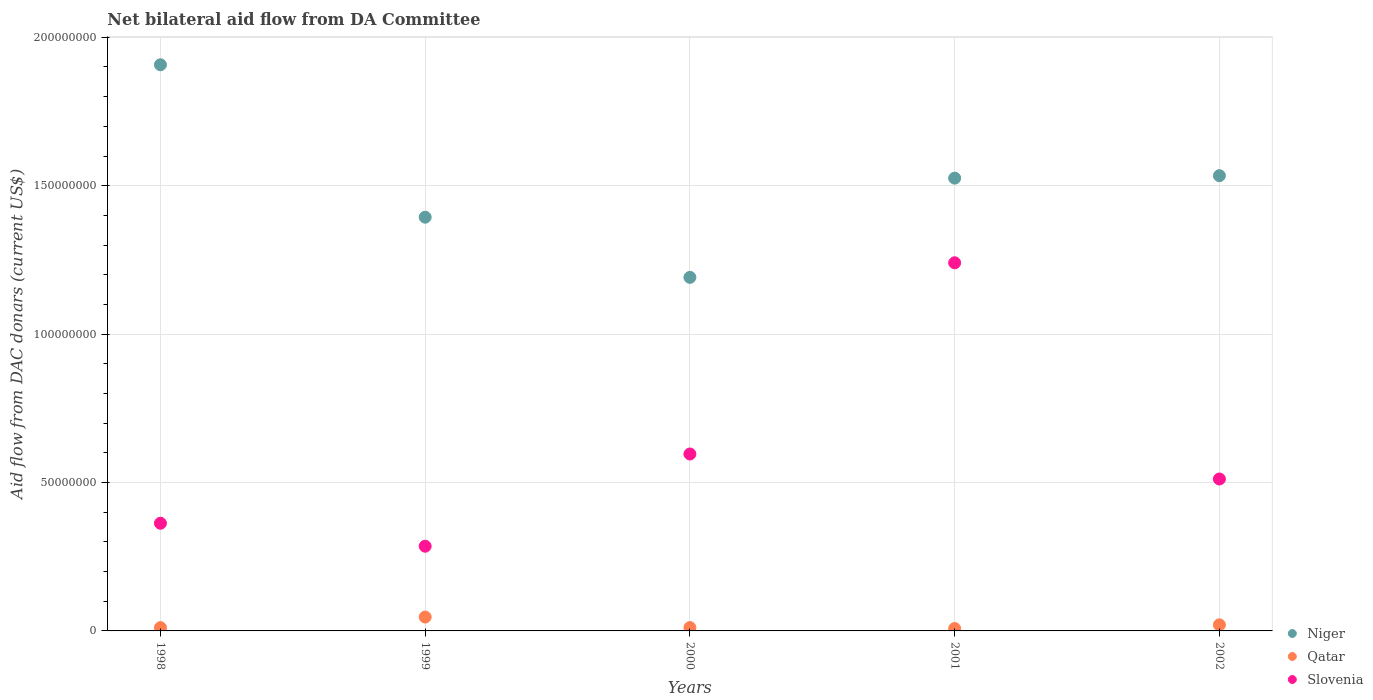How many different coloured dotlines are there?
Give a very brief answer. 3. Is the number of dotlines equal to the number of legend labels?
Provide a succinct answer. Yes. What is the aid flow in in Niger in 1998?
Keep it short and to the point. 1.91e+08. Across all years, what is the maximum aid flow in in Slovenia?
Your answer should be very brief. 1.24e+08. Across all years, what is the minimum aid flow in in Qatar?
Offer a very short reply. 8.10e+05. In which year was the aid flow in in Slovenia maximum?
Make the answer very short. 2001. What is the total aid flow in in Qatar in the graph?
Offer a very short reply. 9.77e+06. What is the difference between the aid flow in in Niger in 1999 and that in 2000?
Your answer should be compact. 2.03e+07. What is the difference between the aid flow in in Niger in 2002 and the aid flow in in Slovenia in 2000?
Your answer should be compact. 9.38e+07. What is the average aid flow in in Qatar per year?
Ensure brevity in your answer.  1.95e+06. In the year 1998, what is the difference between the aid flow in in Qatar and aid flow in in Slovenia?
Offer a very short reply. -3.52e+07. What is the ratio of the aid flow in in Qatar in 1999 to that in 2001?
Provide a succinct answer. 5.78. Is the aid flow in in Qatar in 1999 less than that in 2002?
Give a very brief answer. No. What is the difference between the highest and the second highest aid flow in in Slovenia?
Your answer should be compact. 6.44e+07. What is the difference between the highest and the lowest aid flow in in Qatar?
Your answer should be very brief. 3.87e+06. Is the aid flow in in Niger strictly greater than the aid flow in in Slovenia over the years?
Offer a very short reply. Yes. How many years are there in the graph?
Your answer should be very brief. 5. Does the graph contain any zero values?
Make the answer very short. No. Does the graph contain grids?
Ensure brevity in your answer.  Yes. Where does the legend appear in the graph?
Give a very brief answer. Bottom right. How many legend labels are there?
Provide a short and direct response. 3. How are the legend labels stacked?
Ensure brevity in your answer.  Vertical. What is the title of the graph?
Offer a very short reply. Net bilateral aid flow from DA Committee. What is the label or title of the X-axis?
Provide a short and direct response. Years. What is the label or title of the Y-axis?
Give a very brief answer. Aid flow from DAC donars (current US$). What is the Aid flow from DAC donars (current US$) of Niger in 1998?
Your response must be concise. 1.91e+08. What is the Aid flow from DAC donars (current US$) in Qatar in 1998?
Offer a terse response. 1.11e+06. What is the Aid flow from DAC donars (current US$) of Slovenia in 1998?
Keep it short and to the point. 3.63e+07. What is the Aid flow from DAC donars (current US$) of Niger in 1999?
Keep it short and to the point. 1.39e+08. What is the Aid flow from DAC donars (current US$) in Qatar in 1999?
Keep it short and to the point. 4.68e+06. What is the Aid flow from DAC donars (current US$) of Slovenia in 1999?
Provide a short and direct response. 2.85e+07. What is the Aid flow from DAC donars (current US$) in Niger in 2000?
Your response must be concise. 1.19e+08. What is the Aid flow from DAC donars (current US$) in Qatar in 2000?
Your answer should be compact. 1.12e+06. What is the Aid flow from DAC donars (current US$) in Slovenia in 2000?
Give a very brief answer. 5.96e+07. What is the Aid flow from DAC donars (current US$) of Niger in 2001?
Your answer should be very brief. 1.53e+08. What is the Aid flow from DAC donars (current US$) in Qatar in 2001?
Ensure brevity in your answer.  8.10e+05. What is the Aid flow from DAC donars (current US$) of Slovenia in 2001?
Provide a succinct answer. 1.24e+08. What is the Aid flow from DAC donars (current US$) of Niger in 2002?
Your response must be concise. 1.53e+08. What is the Aid flow from DAC donars (current US$) of Qatar in 2002?
Give a very brief answer. 2.05e+06. What is the Aid flow from DAC donars (current US$) of Slovenia in 2002?
Offer a terse response. 5.12e+07. Across all years, what is the maximum Aid flow from DAC donars (current US$) of Niger?
Make the answer very short. 1.91e+08. Across all years, what is the maximum Aid flow from DAC donars (current US$) in Qatar?
Make the answer very short. 4.68e+06. Across all years, what is the maximum Aid flow from DAC donars (current US$) in Slovenia?
Your answer should be very brief. 1.24e+08. Across all years, what is the minimum Aid flow from DAC donars (current US$) of Niger?
Ensure brevity in your answer.  1.19e+08. Across all years, what is the minimum Aid flow from DAC donars (current US$) of Qatar?
Offer a terse response. 8.10e+05. Across all years, what is the minimum Aid flow from DAC donars (current US$) of Slovenia?
Provide a short and direct response. 2.85e+07. What is the total Aid flow from DAC donars (current US$) of Niger in the graph?
Offer a terse response. 7.55e+08. What is the total Aid flow from DAC donars (current US$) of Qatar in the graph?
Give a very brief answer. 9.77e+06. What is the total Aid flow from DAC donars (current US$) in Slovenia in the graph?
Your response must be concise. 3.00e+08. What is the difference between the Aid flow from DAC donars (current US$) in Niger in 1998 and that in 1999?
Ensure brevity in your answer.  5.14e+07. What is the difference between the Aid flow from DAC donars (current US$) of Qatar in 1998 and that in 1999?
Offer a terse response. -3.57e+06. What is the difference between the Aid flow from DAC donars (current US$) of Slovenia in 1998 and that in 1999?
Your response must be concise. 7.74e+06. What is the difference between the Aid flow from DAC donars (current US$) in Niger in 1998 and that in 2000?
Your answer should be compact. 7.16e+07. What is the difference between the Aid flow from DAC donars (current US$) of Qatar in 1998 and that in 2000?
Offer a very short reply. -10000. What is the difference between the Aid flow from DAC donars (current US$) in Slovenia in 1998 and that in 2000?
Provide a short and direct response. -2.33e+07. What is the difference between the Aid flow from DAC donars (current US$) in Niger in 1998 and that in 2001?
Provide a succinct answer. 3.82e+07. What is the difference between the Aid flow from DAC donars (current US$) of Slovenia in 1998 and that in 2001?
Offer a very short reply. -8.78e+07. What is the difference between the Aid flow from DAC donars (current US$) in Niger in 1998 and that in 2002?
Your answer should be very brief. 3.74e+07. What is the difference between the Aid flow from DAC donars (current US$) of Qatar in 1998 and that in 2002?
Your answer should be compact. -9.40e+05. What is the difference between the Aid flow from DAC donars (current US$) of Slovenia in 1998 and that in 2002?
Your answer should be very brief. -1.49e+07. What is the difference between the Aid flow from DAC donars (current US$) in Niger in 1999 and that in 2000?
Provide a short and direct response. 2.03e+07. What is the difference between the Aid flow from DAC donars (current US$) of Qatar in 1999 and that in 2000?
Give a very brief answer. 3.56e+06. What is the difference between the Aid flow from DAC donars (current US$) in Slovenia in 1999 and that in 2000?
Keep it short and to the point. -3.11e+07. What is the difference between the Aid flow from DAC donars (current US$) in Niger in 1999 and that in 2001?
Give a very brief answer. -1.32e+07. What is the difference between the Aid flow from DAC donars (current US$) in Qatar in 1999 and that in 2001?
Offer a terse response. 3.87e+06. What is the difference between the Aid flow from DAC donars (current US$) of Slovenia in 1999 and that in 2001?
Make the answer very short. -9.55e+07. What is the difference between the Aid flow from DAC donars (current US$) in Niger in 1999 and that in 2002?
Provide a succinct answer. -1.40e+07. What is the difference between the Aid flow from DAC donars (current US$) in Qatar in 1999 and that in 2002?
Keep it short and to the point. 2.63e+06. What is the difference between the Aid flow from DAC donars (current US$) of Slovenia in 1999 and that in 2002?
Provide a succinct answer. -2.26e+07. What is the difference between the Aid flow from DAC donars (current US$) of Niger in 2000 and that in 2001?
Provide a succinct answer. -3.34e+07. What is the difference between the Aid flow from DAC donars (current US$) of Qatar in 2000 and that in 2001?
Offer a terse response. 3.10e+05. What is the difference between the Aid flow from DAC donars (current US$) in Slovenia in 2000 and that in 2001?
Keep it short and to the point. -6.44e+07. What is the difference between the Aid flow from DAC donars (current US$) of Niger in 2000 and that in 2002?
Your answer should be compact. -3.43e+07. What is the difference between the Aid flow from DAC donars (current US$) of Qatar in 2000 and that in 2002?
Offer a terse response. -9.30e+05. What is the difference between the Aid flow from DAC donars (current US$) of Slovenia in 2000 and that in 2002?
Provide a succinct answer. 8.42e+06. What is the difference between the Aid flow from DAC donars (current US$) of Niger in 2001 and that in 2002?
Make the answer very short. -8.30e+05. What is the difference between the Aid flow from DAC donars (current US$) in Qatar in 2001 and that in 2002?
Offer a terse response. -1.24e+06. What is the difference between the Aid flow from DAC donars (current US$) of Slovenia in 2001 and that in 2002?
Provide a succinct answer. 7.28e+07. What is the difference between the Aid flow from DAC donars (current US$) in Niger in 1998 and the Aid flow from DAC donars (current US$) in Qatar in 1999?
Provide a short and direct response. 1.86e+08. What is the difference between the Aid flow from DAC donars (current US$) of Niger in 1998 and the Aid flow from DAC donars (current US$) of Slovenia in 1999?
Keep it short and to the point. 1.62e+08. What is the difference between the Aid flow from DAC donars (current US$) in Qatar in 1998 and the Aid flow from DAC donars (current US$) in Slovenia in 1999?
Give a very brief answer. -2.74e+07. What is the difference between the Aid flow from DAC donars (current US$) of Niger in 1998 and the Aid flow from DAC donars (current US$) of Qatar in 2000?
Your answer should be compact. 1.90e+08. What is the difference between the Aid flow from DAC donars (current US$) in Niger in 1998 and the Aid flow from DAC donars (current US$) in Slovenia in 2000?
Keep it short and to the point. 1.31e+08. What is the difference between the Aid flow from DAC donars (current US$) in Qatar in 1998 and the Aid flow from DAC donars (current US$) in Slovenia in 2000?
Give a very brief answer. -5.85e+07. What is the difference between the Aid flow from DAC donars (current US$) in Niger in 1998 and the Aid flow from DAC donars (current US$) in Qatar in 2001?
Ensure brevity in your answer.  1.90e+08. What is the difference between the Aid flow from DAC donars (current US$) in Niger in 1998 and the Aid flow from DAC donars (current US$) in Slovenia in 2001?
Offer a very short reply. 6.67e+07. What is the difference between the Aid flow from DAC donars (current US$) of Qatar in 1998 and the Aid flow from DAC donars (current US$) of Slovenia in 2001?
Ensure brevity in your answer.  -1.23e+08. What is the difference between the Aid flow from DAC donars (current US$) in Niger in 1998 and the Aid flow from DAC donars (current US$) in Qatar in 2002?
Provide a short and direct response. 1.89e+08. What is the difference between the Aid flow from DAC donars (current US$) of Niger in 1998 and the Aid flow from DAC donars (current US$) of Slovenia in 2002?
Your answer should be very brief. 1.40e+08. What is the difference between the Aid flow from DAC donars (current US$) in Qatar in 1998 and the Aid flow from DAC donars (current US$) in Slovenia in 2002?
Keep it short and to the point. -5.01e+07. What is the difference between the Aid flow from DAC donars (current US$) of Niger in 1999 and the Aid flow from DAC donars (current US$) of Qatar in 2000?
Provide a succinct answer. 1.38e+08. What is the difference between the Aid flow from DAC donars (current US$) in Niger in 1999 and the Aid flow from DAC donars (current US$) in Slovenia in 2000?
Your response must be concise. 7.98e+07. What is the difference between the Aid flow from DAC donars (current US$) of Qatar in 1999 and the Aid flow from DAC donars (current US$) of Slovenia in 2000?
Make the answer very short. -5.49e+07. What is the difference between the Aid flow from DAC donars (current US$) of Niger in 1999 and the Aid flow from DAC donars (current US$) of Qatar in 2001?
Provide a succinct answer. 1.39e+08. What is the difference between the Aid flow from DAC donars (current US$) in Niger in 1999 and the Aid flow from DAC donars (current US$) in Slovenia in 2001?
Your answer should be very brief. 1.54e+07. What is the difference between the Aid flow from DAC donars (current US$) of Qatar in 1999 and the Aid flow from DAC donars (current US$) of Slovenia in 2001?
Your answer should be compact. -1.19e+08. What is the difference between the Aid flow from DAC donars (current US$) of Niger in 1999 and the Aid flow from DAC donars (current US$) of Qatar in 2002?
Keep it short and to the point. 1.37e+08. What is the difference between the Aid flow from DAC donars (current US$) of Niger in 1999 and the Aid flow from DAC donars (current US$) of Slovenia in 2002?
Your response must be concise. 8.82e+07. What is the difference between the Aid flow from DAC donars (current US$) in Qatar in 1999 and the Aid flow from DAC donars (current US$) in Slovenia in 2002?
Offer a very short reply. -4.65e+07. What is the difference between the Aid flow from DAC donars (current US$) of Niger in 2000 and the Aid flow from DAC donars (current US$) of Qatar in 2001?
Offer a terse response. 1.18e+08. What is the difference between the Aid flow from DAC donars (current US$) in Niger in 2000 and the Aid flow from DAC donars (current US$) in Slovenia in 2001?
Provide a succinct answer. -4.91e+06. What is the difference between the Aid flow from DAC donars (current US$) in Qatar in 2000 and the Aid flow from DAC donars (current US$) in Slovenia in 2001?
Your response must be concise. -1.23e+08. What is the difference between the Aid flow from DAC donars (current US$) in Niger in 2000 and the Aid flow from DAC donars (current US$) in Qatar in 2002?
Offer a terse response. 1.17e+08. What is the difference between the Aid flow from DAC donars (current US$) in Niger in 2000 and the Aid flow from DAC donars (current US$) in Slovenia in 2002?
Your answer should be very brief. 6.79e+07. What is the difference between the Aid flow from DAC donars (current US$) in Qatar in 2000 and the Aid flow from DAC donars (current US$) in Slovenia in 2002?
Give a very brief answer. -5.01e+07. What is the difference between the Aid flow from DAC donars (current US$) in Niger in 2001 and the Aid flow from DAC donars (current US$) in Qatar in 2002?
Ensure brevity in your answer.  1.50e+08. What is the difference between the Aid flow from DAC donars (current US$) of Niger in 2001 and the Aid flow from DAC donars (current US$) of Slovenia in 2002?
Your answer should be very brief. 1.01e+08. What is the difference between the Aid flow from DAC donars (current US$) of Qatar in 2001 and the Aid flow from DAC donars (current US$) of Slovenia in 2002?
Make the answer very short. -5.04e+07. What is the average Aid flow from DAC donars (current US$) of Niger per year?
Offer a terse response. 1.51e+08. What is the average Aid flow from DAC donars (current US$) in Qatar per year?
Your answer should be compact. 1.95e+06. What is the average Aid flow from DAC donars (current US$) in Slovenia per year?
Provide a short and direct response. 5.99e+07. In the year 1998, what is the difference between the Aid flow from DAC donars (current US$) in Niger and Aid flow from DAC donars (current US$) in Qatar?
Your answer should be compact. 1.90e+08. In the year 1998, what is the difference between the Aid flow from DAC donars (current US$) of Niger and Aid flow from DAC donars (current US$) of Slovenia?
Give a very brief answer. 1.54e+08. In the year 1998, what is the difference between the Aid flow from DAC donars (current US$) of Qatar and Aid flow from DAC donars (current US$) of Slovenia?
Keep it short and to the point. -3.52e+07. In the year 1999, what is the difference between the Aid flow from DAC donars (current US$) in Niger and Aid flow from DAC donars (current US$) in Qatar?
Give a very brief answer. 1.35e+08. In the year 1999, what is the difference between the Aid flow from DAC donars (current US$) in Niger and Aid flow from DAC donars (current US$) in Slovenia?
Provide a short and direct response. 1.11e+08. In the year 1999, what is the difference between the Aid flow from DAC donars (current US$) in Qatar and Aid flow from DAC donars (current US$) in Slovenia?
Your answer should be very brief. -2.39e+07. In the year 2000, what is the difference between the Aid flow from DAC donars (current US$) in Niger and Aid flow from DAC donars (current US$) in Qatar?
Give a very brief answer. 1.18e+08. In the year 2000, what is the difference between the Aid flow from DAC donars (current US$) in Niger and Aid flow from DAC donars (current US$) in Slovenia?
Your answer should be compact. 5.95e+07. In the year 2000, what is the difference between the Aid flow from DAC donars (current US$) of Qatar and Aid flow from DAC donars (current US$) of Slovenia?
Provide a succinct answer. -5.85e+07. In the year 2001, what is the difference between the Aid flow from DAC donars (current US$) in Niger and Aid flow from DAC donars (current US$) in Qatar?
Keep it short and to the point. 1.52e+08. In the year 2001, what is the difference between the Aid flow from DAC donars (current US$) of Niger and Aid flow from DAC donars (current US$) of Slovenia?
Provide a succinct answer. 2.85e+07. In the year 2001, what is the difference between the Aid flow from DAC donars (current US$) in Qatar and Aid flow from DAC donars (current US$) in Slovenia?
Keep it short and to the point. -1.23e+08. In the year 2002, what is the difference between the Aid flow from DAC donars (current US$) of Niger and Aid flow from DAC donars (current US$) of Qatar?
Ensure brevity in your answer.  1.51e+08. In the year 2002, what is the difference between the Aid flow from DAC donars (current US$) of Niger and Aid flow from DAC donars (current US$) of Slovenia?
Your response must be concise. 1.02e+08. In the year 2002, what is the difference between the Aid flow from DAC donars (current US$) in Qatar and Aid flow from DAC donars (current US$) in Slovenia?
Provide a short and direct response. -4.91e+07. What is the ratio of the Aid flow from DAC donars (current US$) in Niger in 1998 to that in 1999?
Keep it short and to the point. 1.37. What is the ratio of the Aid flow from DAC donars (current US$) in Qatar in 1998 to that in 1999?
Ensure brevity in your answer.  0.24. What is the ratio of the Aid flow from DAC donars (current US$) in Slovenia in 1998 to that in 1999?
Give a very brief answer. 1.27. What is the ratio of the Aid flow from DAC donars (current US$) in Niger in 1998 to that in 2000?
Your answer should be compact. 1.6. What is the ratio of the Aid flow from DAC donars (current US$) of Slovenia in 1998 to that in 2000?
Give a very brief answer. 0.61. What is the ratio of the Aid flow from DAC donars (current US$) in Niger in 1998 to that in 2001?
Your response must be concise. 1.25. What is the ratio of the Aid flow from DAC donars (current US$) in Qatar in 1998 to that in 2001?
Your answer should be compact. 1.37. What is the ratio of the Aid flow from DAC donars (current US$) of Slovenia in 1998 to that in 2001?
Your answer should be very brief. 0.29. What is the ratio of the Aid flow from DAC donars (current US$) of Niger in 1998 to that in 2002?
Keep it short and to the point. 1.24. What is the ratio of the Aid flow from DAC donars (current US$) of Qatar in 1998 to that in 2002?
Ensure brevity in your answer.  0.54. What is the ratio of the Aid flow from DAC donars (current US$) in Slovenia in 1998 to that in 2002?
Offer a terse response. 0.71. What is the ratio of the Aid flow from DAC donars (current US$) of Niger in 1999 to that in 2000?
Your answer should be very brief. 1.17. What is the ratio of the Aid flow from DAC donars (current US$) of Qatar in 1999 to that in 2000?
Provide a short and direct response. 4.18. What is the ratio of the Aid flow from DAC donars (current US$) in Slovenia in 1999 to that in 2000?
Your response must be concise. 0.48. What is the ratio of the Aid flow from DAC donars (current US$) of Niger in 1999 to that in 2001?
Give a very brief answer. 0.91. What is the ratio of the Aid flow from DAC donars (current US$) of Qatar in 1999 to that in 2001?
Ensure brevity in your answer.  5.78. What is the ratio of the Aid flow from DAC donars (current US$) of Slovenia in 1999 to that in 2001?
Offer a very short reply. 0.23. What is the ratio of the Aid flow from DAC donars (current US$) of Niger in 1999 to that in 2002?
Give a very brief answer. 0.91. What is the ratio of the Aid flow from DAC donars (current US$) in Qatar in 1999 to that in 2002?
Provide a succinct answer. 2.28. What is the ratio of the Aid flow from DAC donars (current US$) in Slovenia in 1999 to that in 2002?
Provide a short and direct response. 0.56. What is the ratio of the Aid flow from DAC donars (current US$) in Niger in 2000 to that in 2001?
Provide a short and direct response. 0.78. What is the ratio of the Aid flow from DAC donars (current US$) in Qatar in 2000 to that in 2001?
Give a very brief answer. 1.38. What is the ratio of the Aid flow from DAC donars (current US$) in Slovenia in 2000 to that in 2001?
Offer a terse response. 0.48. What is the ratio of the Aid flow from DAC donars (current US$) in Niger in 2000 to that in 2002?
Give a very brief answer. 0.78. What is the ratio of the Aid flow from DAC donars (current US$) in Qatar in 2000 to that in 2002?
Your answer should be very brief. 0.55. What is the ratio of the Aid flow from DAC donars (current US$) of Slovenia in 2000 to that in 2002?
Keep it short and to the point. 1.16. What is the ratio of the Aid flow from DAC donars (current US$) of Niger in 2001 to that in 2002?
Provide a short and direct response. 0.99. What is the ratio of the Aid flow from DAC donars (current US$) of Qatar in 2001 to that in 2002?
Ensure brevity in your answer.  0.4. What is the ratio of the Aid flow from DAC donars (current US$) of Slovenia in 2001 to that in 2002?
Offer a terse response. 2.42. What is the difference between the highest and the second highest Aid flow from DAC donars (current US$) of Niger?
Give a very brief answer. 3.74e+07. What is the difference between the highest and the second highest Aid flow from DAC donars (current US$) of Qatar?
Make the answer very short. 2.63e+06. What is the difference between the highest and the second highest Aid flow from DAC donars (current US$) of Slovenia?
Offer a very short reply. 6.44e+07. What is the difference between the highest and the lowest Aid flow from DAC donars (current US$) in Niger?
Give a very brief answer. 7.16e+07. What is the difference between the highest and the lowest Aid flow from DAC donars (current US$) in Qatar?
Provide a short and direct response. 3.87e+06. What is the difference between the highest and the lowest Aid flow from DAC donars (current US$) in Slovenia?
Keep it short and to the point. 9.55e+07. 